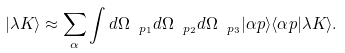<formula> <loc_0><loc_0><loc_500><loc_500>| \lambda { K } \rangle \approx \sum _ { \alpha } \int d \Omega _ { \ p _ { 1 } } d \Omega _ { \ p _ { 2 } } d \Omega _ { \ p _ { 3 } } | \alpha { p } \rangle \langle \alpha { p } | \lambda { K } \rangle .</formula> 